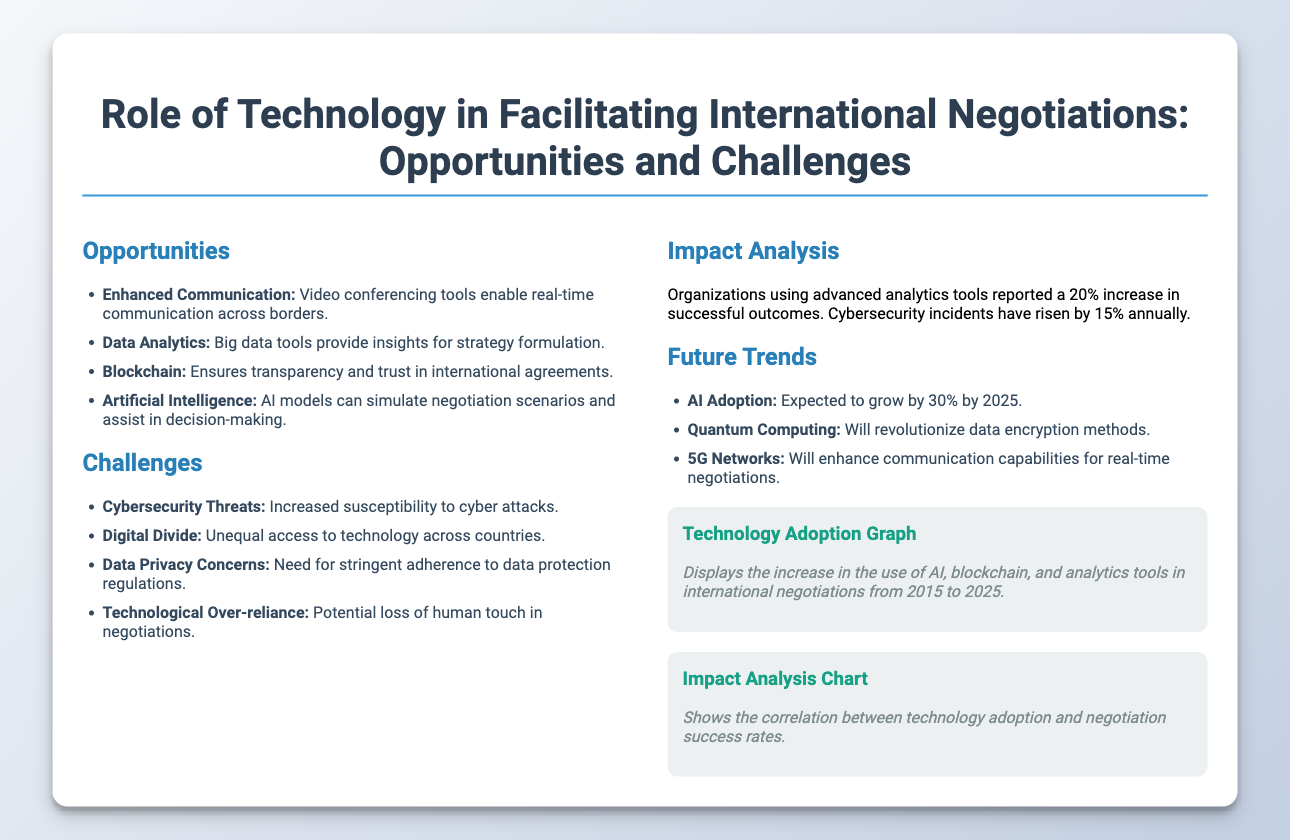What are the four opportunities presented? The document lists four opportunities which include enhanced communication, data analytics, blockchain, and artificial intelligence.
Answer: Enhanced communication, data analytics, blockchain, artificial intelligence What percentage increase in successful outcomes is reported by organizations using advanced analytics? The document states that organizations using advanced analytics tools reported a 20% increase in successful outcomes.
Answer: 20% What is a major challenge related to international negotiations mentioned in the document? The document outlines several challenges, one of which is cybersecurity threats, indicating the increased risk of cyber attacks.
Answer: Cybersecurity threats By what percentage is AI adoption expected to grow by 2025? The document mentions that AI adoption is expected to grow by 30% by the year 2025.
Answer: 30% What is the role of blockchain as stated in the opportunities section? The document highlights that blockchain ensures transparency and trust in international agreements, which is crucial for negotiations.
Answer: Transparency and trust What are the future trends in technology for international negotiations listed? The future trends identified in the document include AI adoption, quantum computing, and 5G networks, all contributing to negotiation processes.
Answer: AI adoption, quantum computing, 5G networks What does the technology adoption graph illustrate? The graph illustrates the increase in the use of AI, blockchain, and analytics tools in international negotiations from 2015 to 2025.
Answer: Increase in use of AI, blockchain, and analytics tools What organizational impact is linked to technology adoption? The document notes that a correlation exists between technology adoption and increased negotiation success rates, evidenced by reported outcomes.
Answer: Increased negotiation success rates What does the impact analysis indicate about cybersecurity incidents? The document states that cybersecurity incidents have risen by 15% annually, reflecting the associated risks of technology use.
Answer: 15% annually 